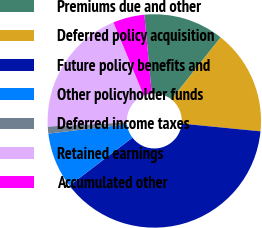Convert chart. <chart><loc_0><loc_0><loc_500><loc_500><pie_chart><fcel>Premiums due and other<fcel>Deferred policy acquisition<fcel>Future policy benefits and<fcel>Other policyholder funds<fcel>Deferred income taxes<fcel>Retained earnings<fcel>Accumulated other<nl><fcel>12.17%<fcel>15.87%<fcel>38.09%<fcel>8.47%<fcel>1.06%<fcel>19.57%<fcel>4.77%<nl></chart> 